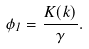<formula> <loc_0><loc_0><loc_500><loc_500>\phi _ { 1 } = \frac { K ( k ) } { \gamma } .</formula> 